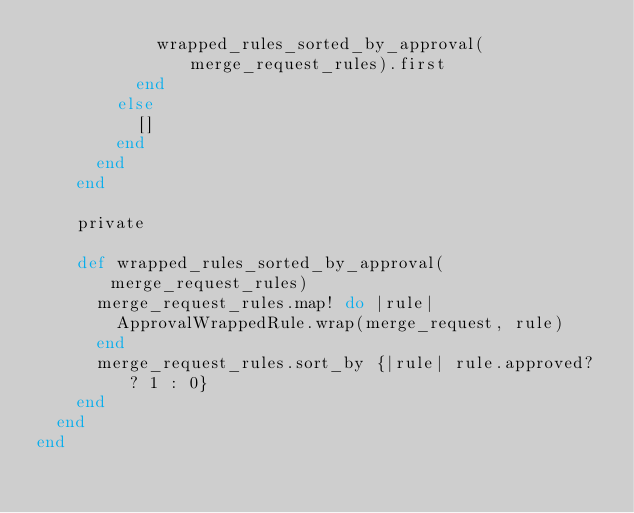<code> <loc_0><loc_0><loc_500><loc_500><_Ruby_>            wrapped_rules_sorted_by_approval(merge_request_rules).first
          end
        else
          []
        end
      end
    end

    private

    def wrapped_rules_sorted_by_approval(merge_request_rules)
      merge_request_rules.map! do |rule|
        ApprovalWrappedRule.wrap(merge_request, rule)
      end
      merge_request_rules.sort_by {|rule| rule.approved? ? 1 : 0}
    end
  end
end
</code> 